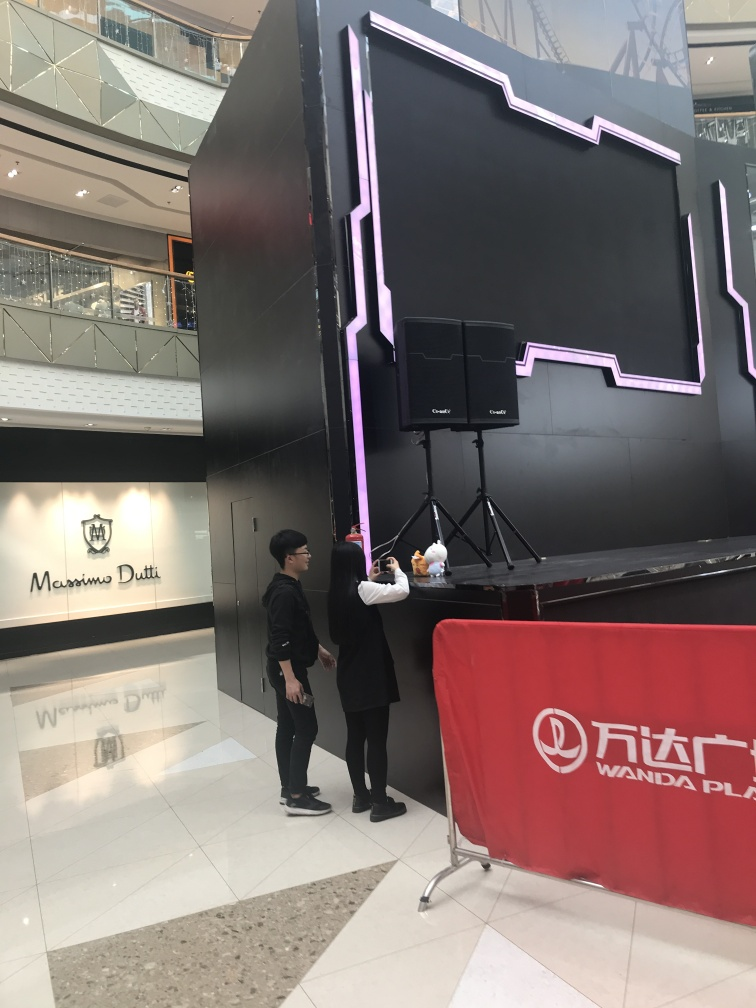Are there any quality issues with this image? The image appears to be clear and well-lit, showing two individuals and a large structure with neon lights. There are no immediately apparent quality issues such as blurriness or distortion; however, the composition might be improved by capturing the full context of the neon-lit structure, as the top portion is cut off. 